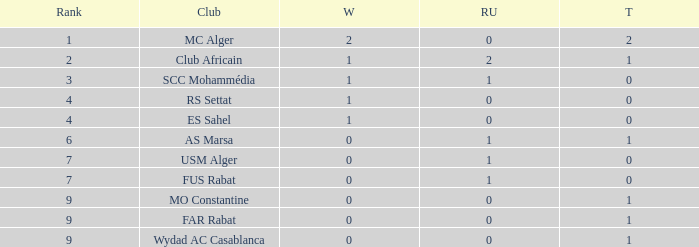How many Winners have a Third of 1, and Runners-up smaller than 0? 0.0. Can you give me this table as a dict? {'header': ['Rank', 'Club', 'W', 'RU', 'T'], 'rows': [['1', 'MC Alger', '2', '0', '2'], ['2', 'Club Africain', '1', '2', '1'], ['3', 'SCC Mohammédia', '1', '1', '0'], ['4', 'RS Settat', '1', '0', '0'], ['4', 'ES Sahel', '1', '0', '0'], ['6', 'AS Marsa', '0', '1', '1'], ['7', 'USM Alger', '0', '1', '0'], ['7', 'FUS Rabat', '0', '1', '0'], ['9', 'MO Constantine', '0', '0', '1'], ['9', 'FAR Rabat', '0', '0', '1'], ['9', 'Wydad AC Casablanca', '0', '0', '1']]} 